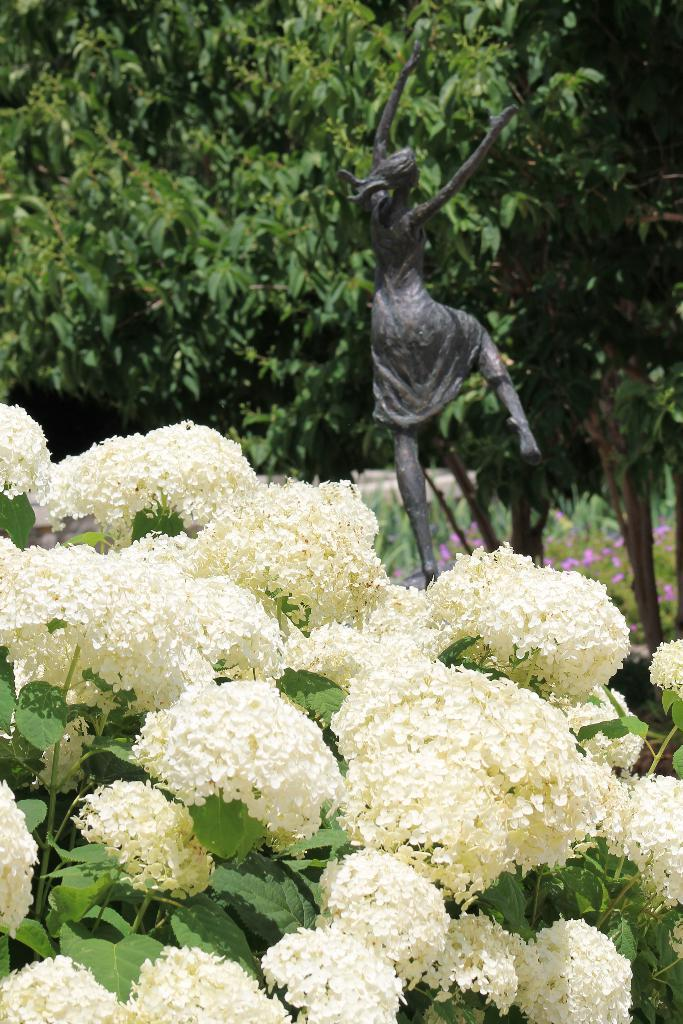What type of flowers can be seen in the image? There are white-colored flowers in the image. What color are the leaves associated with the flowers? There are green-colored leaves in the image. What can be seen in the background of the image? There is a sculpture of a woman and trees in the background. Can you see any books being carried by the squirrel in the image? There is no squirrel present in the image, so it is not possible to see any books being carried by a squirrel. 